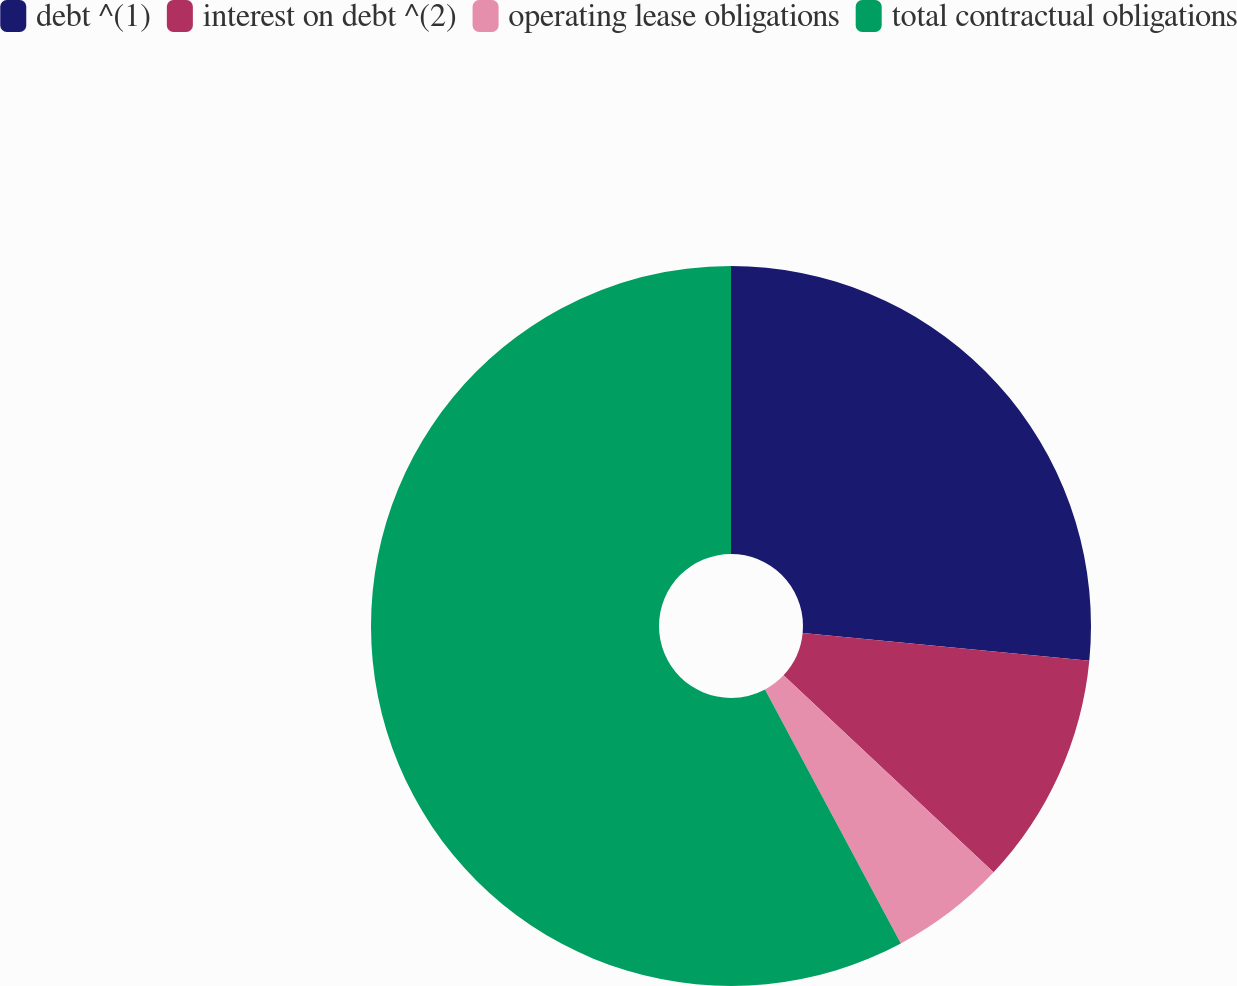Convert chart. <chart><loc_0><loc_0><loc_500><loc_500><pie_chart><fcel>debt ^(1)<fcel>interest on debt ^(2)<fcel>operating lease obligations<fcel>total contractual obligations<nl><fcel>26.54%<fcel>10.45%<fcel>5.19%<fcel>57.82%<nl></chart> 